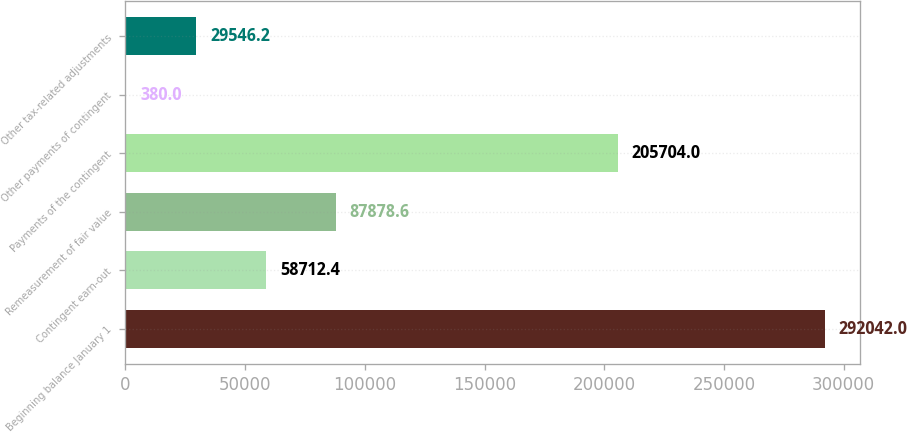<chart> <loc_0><loc_0><loc_500><loc_500><bar_chart><fcel>Beginning balance January 1<fcel>Contingent earn-out<fcel>Remeasurement of fair value<fcel>Payments of the contingent<fcel>Other payments of contingent<fcel>Other tax-related adjustments<nl><fcel>292042<fcel>58712.4<fcel>87878.6<fcel>205704<fcel>380<fcel>29546.2<nl></chart> 